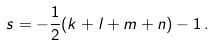Convert formula to latex. <formula><loc_0><loc_0><loc_500><loc_500>s = - \frac { 1 } { 2 } ( k + l + m + n ) - 1 \, .</formula> 